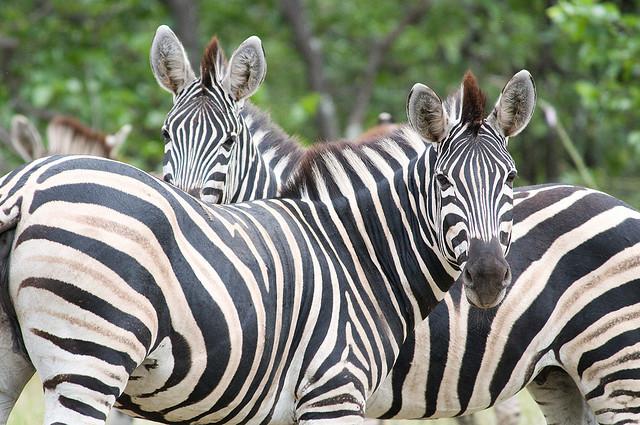Are all of the zebras adults?
Keep it brief. Yes. Are these mothers of elephants?
Concise answer only. No. How many zebra are standing next to each other?
Short answer required. 2. Does each zebra have a mane?
Quick response, please. Yes. Are there any horses?
Be succinct. No. 